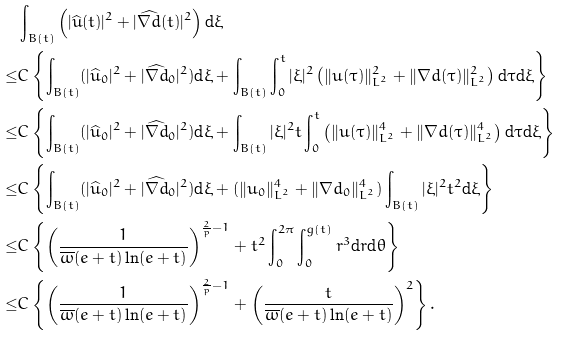Convert formula to latex. <formula><loc_0><loc_0><loc_500><loc_500>& \int _ { B ( t ) } \left ( | \widehat { u } ( t ) | ^ { 2 } + | \widehat { \nabla d } ( t ) | ^ { 2 } \right ) \text {d} \xi \\ \leq & C \left \{ \int _ { B ( t ) } ( | \widehat { u } _ { 0 } | ^ { 2 } + | \widehat { \nabla d } _ { 0 } | ^ { 2 } ) \text {d} \xi + \int _ { B ( t ) } \int _ { 0 } ^ { t } | \xi | ^ { 2 } \left ( \| u ( \tau ) \| _ { L ^ { 2 } } ^ { 2 } + \| \nabla d ( \tau ) \| _ { L ^ { 2 } } ^ { 2 } \right ) \text {d} \tau \text {d} \xi \right \} \\ \leq & C \left \{ \int _ { B ( t ) } ( | \widehat { u } _ { 0 } | ^ { 2 } + | \widehat { \nabla d } _ { 0 } | ^ { 2 } ) \text {d} \xi + \int _ { B ( t ) } | \xi | ^ { 2 } t \int _ { 0 } ^ { t } \left ( \| u ( \tau ) \| _ { L ^ { 2 } } ^ { 4 } + \| \nabla d ( \tau ) \| _ { L ^ { 2 } } ^ { 4 } \right ) \text {d} \tau \text {d} \xi \right \} \\ \leq & C \left \{ \int _ { B ( t ) } ( | \widehat { u } _ { 0 } | ^ { 2 } + | \widehat { \nabla d } _ { 0 } | ^ { 2 } ) \text {d} \xi + ( \| u _ { 0 } \| _ { L ^ { 2 } } ^ { 4 } + \| \nabla d _ { 0 } \| _ { L ^ { 2 } } ^ { 4 } ) \int _ { B ( t ) } | \xi | ^ { 2 } t ^ { 2 } \text {d} \xi \right \} \\ \leq & C \left \{ \left ( \frac { 1 } { \overline { \omega } ( e + t ) \ln ( e + t ) } \right ) ^ { \frac { 2 } { p } - 1 } + t ^ { 2 } \int _ { 0 } ^ { 2 \pi } \int _ { 0 } ^ { g ( t ) } r ^ { 3 } \text {d} r \text {d} \theta \right \} \\ \leq & C \left \{ \left ( \frac { 1 } { \overline { \omega } ( e + t ) \ln ( e + t ) } \right ) ^ { \frac { 2 } { p } - 1 } + \left ( \frac { t } { \overline { \omega } ( e + t ) \ln ( e + t ) } \right ) ^ { 2 } \right \} .</formula> 